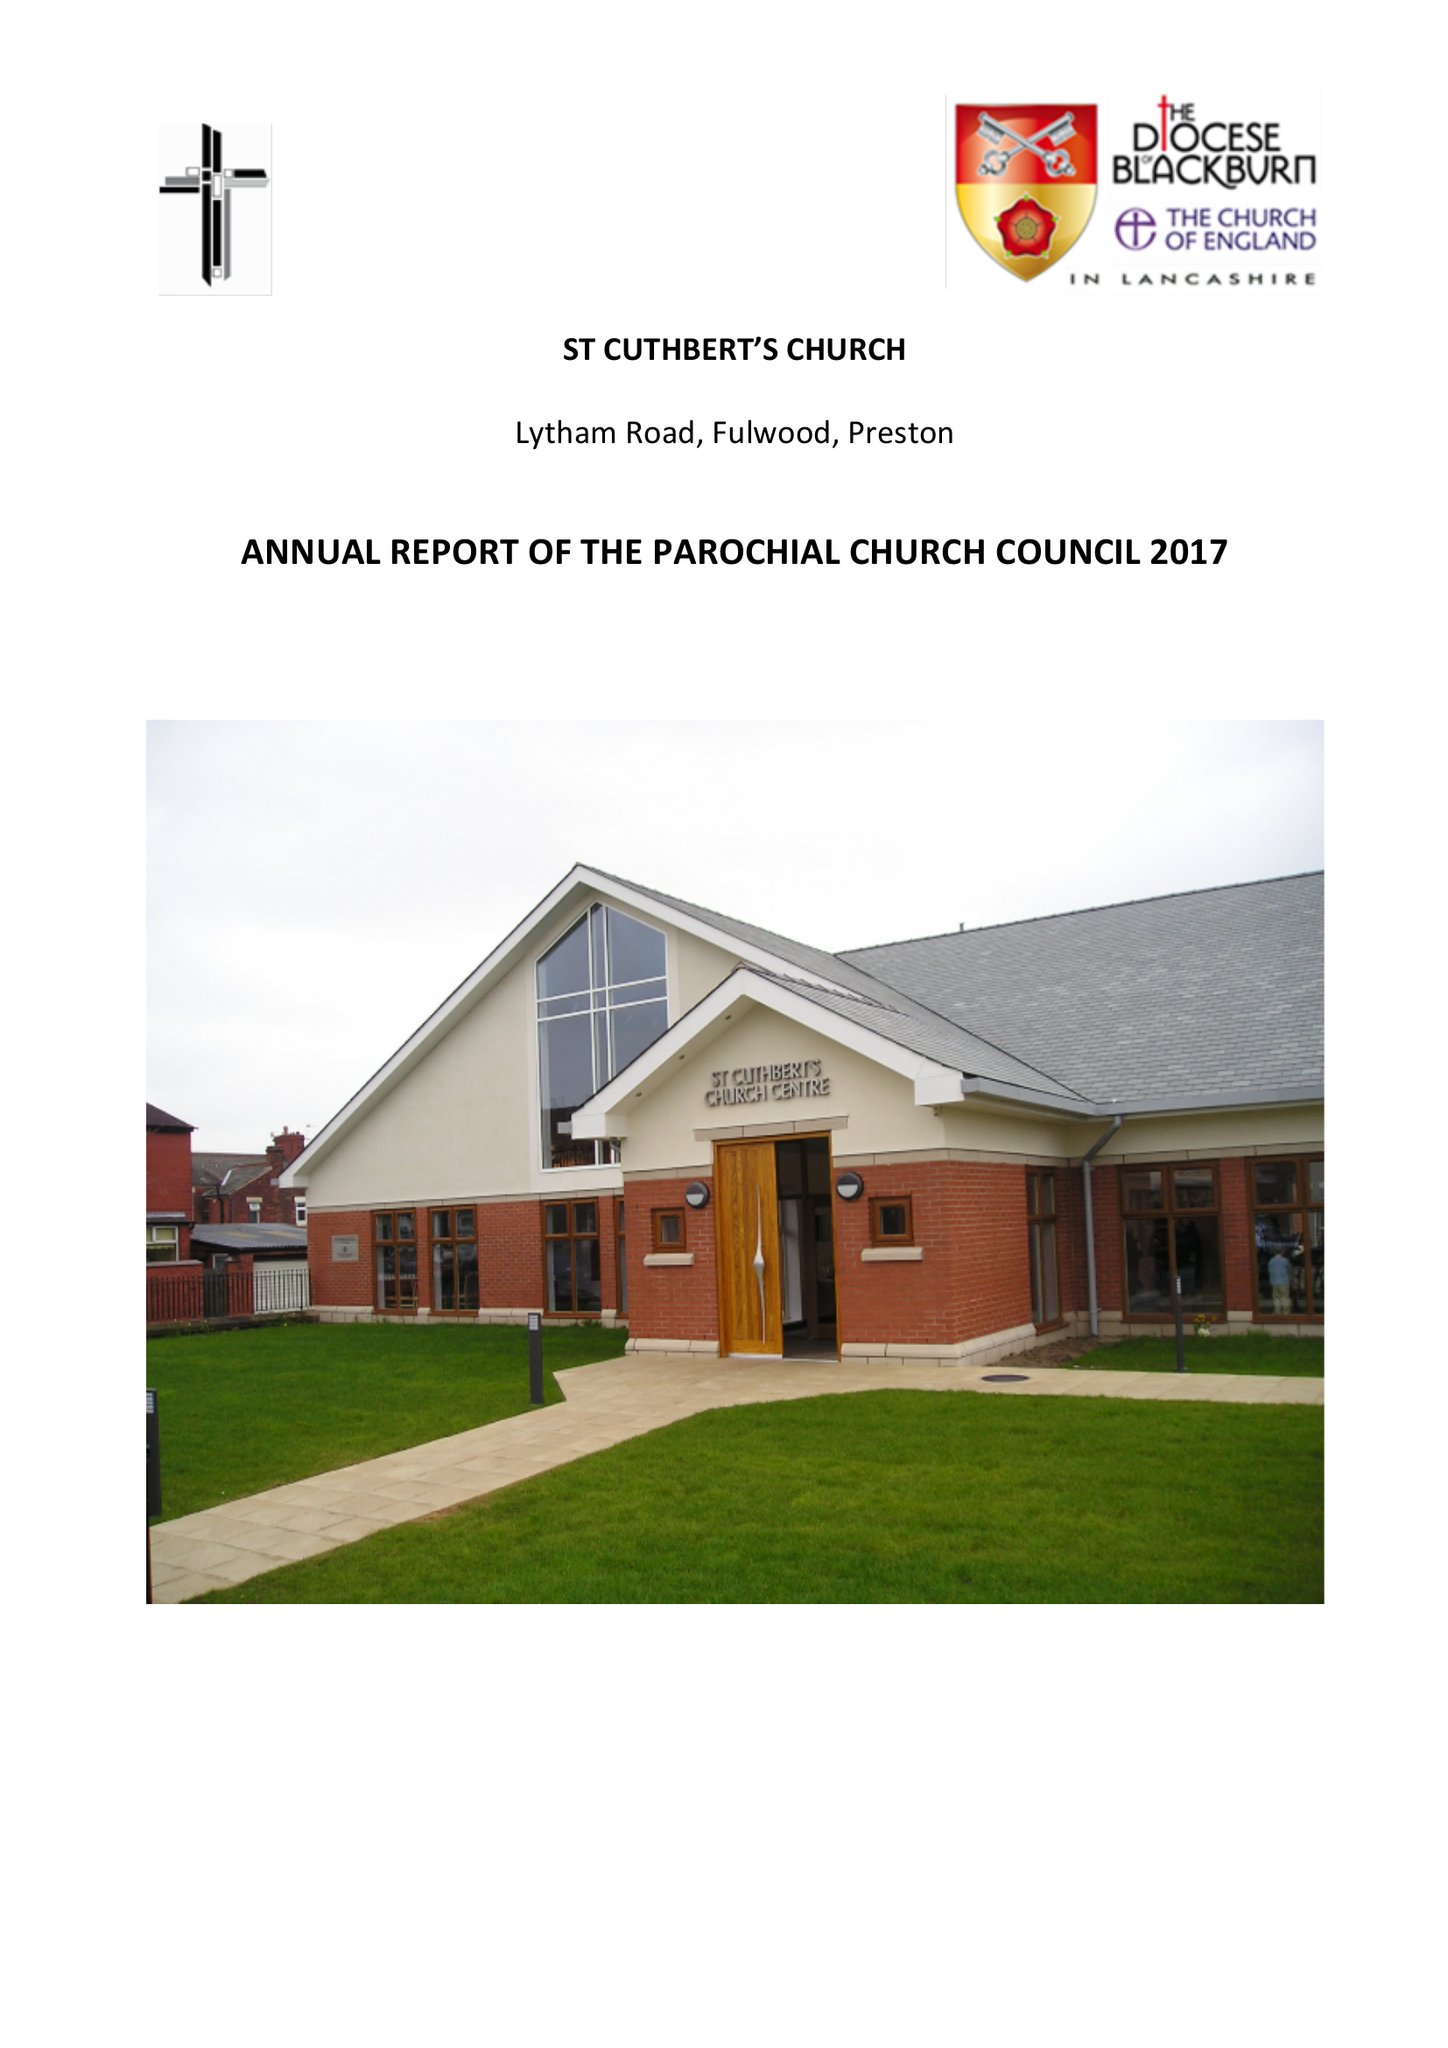What is the value for the spending_annually_in_british_pounds?
Answer the question using a single word or phrase. 142797.46 